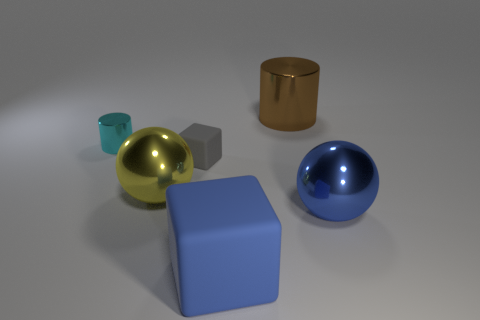Do the object that is behind the tiny cyan cylinder and the tiny object that is on the right side of the yellow metallic thing have the same material?
Your answer should be compact. No. What number of metallic things have the same color as the large block?
Your answer should be very brief. 1. Is the brown cylinder made of the same material as the gray object?
Keep it short and to the point. No. What number of blue objects are made of the same material as the yellow sphere?
Ensure brevity in your answer.  1. There is a large shiny ball right of the big blue matte object; is its color the same as the large matte block?
Make the answer very short. Yes. How many other small gray things are the same shape as the tiny gray object?
Make the answer very short. 0. Is the number of large metal balls that are to the right of the big brown metallic thing the same as the number of large gray objects?
Make the answer very short. No. There is a cylinder that is the same size as the gray thing; what color is it?
Your answer should be compact. Cyan. Is there a tiny shiny object of the same shape as the big brown object?
Make the answer very short. Yes. There is a block in front of the sphere that is on the left side of the small thing that is to the right of the tiny cyan object; what is it made of?
Ensure brevity in your answer.  Rubber. 